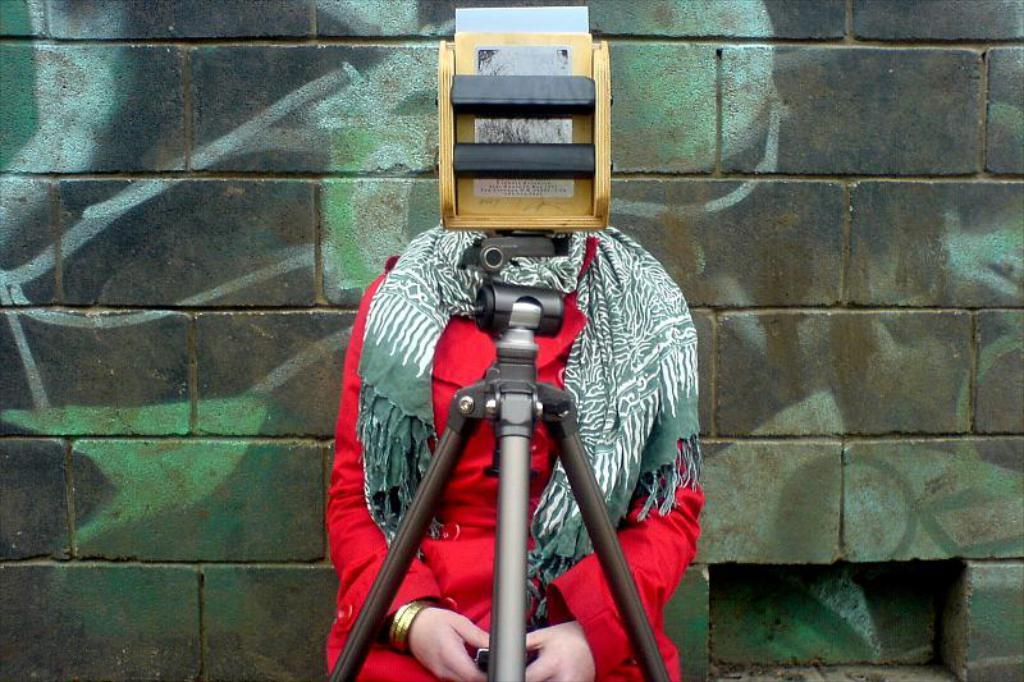What is the main subject of the image? There is a person sitting in front of the camera. Can you describe the person's clothing? The person is wearing a dress with red, green, and white colors. What can be seen in the background of the image? There is a wall in the background of the image. What type of structure is the person pointing to in the image? There is no indication in the image that the person is pointing to any structure. 